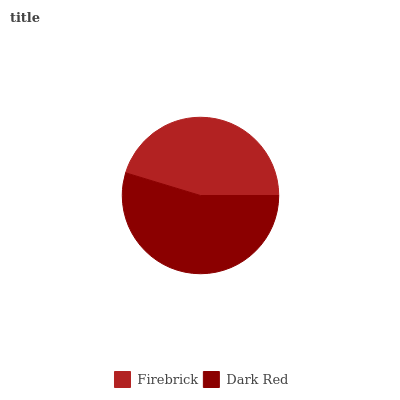Is Firebrick the minimum?
Answer yes or no. Yes. Is Dark Red the maximum?
Answer yes or no. Yes. Is Dark Red the minimum?
Answer yes or no. No. Is Dark Red greater than Firebrick?
Answer yes or no. Yes. Is Firebrick less than Dark Red?
Answer yes or no. Yes. Is Firebrick greater than Dark Red?
Answer yes or no. No. Is Dark Red less than Firebrick?
Answer yes or no. No. Is Dark Red the high median?
Answer yes or no. Yes. Is Firebrick the low median?
Answer yes or no. Yes. Is Firebrick the high median?
Answer yes or no. No. Is Dark Red the low median?
Answer yes or no. No. 